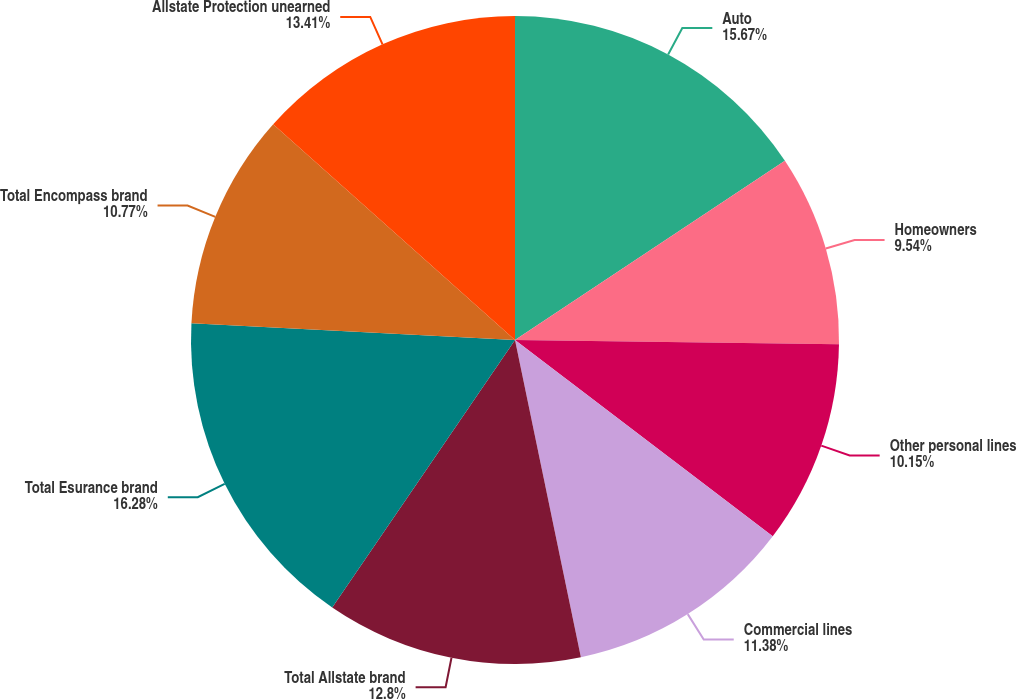<chart> <loc_0><loc_0><loc_500><loc_500><pie_chart><fcel>Auto<fcel>Homeowners<fcel>Other personal lines<fcel>Commercial lines<fcel>Total Allstate brand<fcel>Total Esurance brand<fcel>Total Encompass brand<fcel>Allstate Protection unearned<nl><fcel>15.67%<fcel>9.54%<fcel>10.15%<fcel>11.38%<fcel>12.8%<fcel>16.28%<fcel>10.77%<fcel>13.41%<nl></chart> 